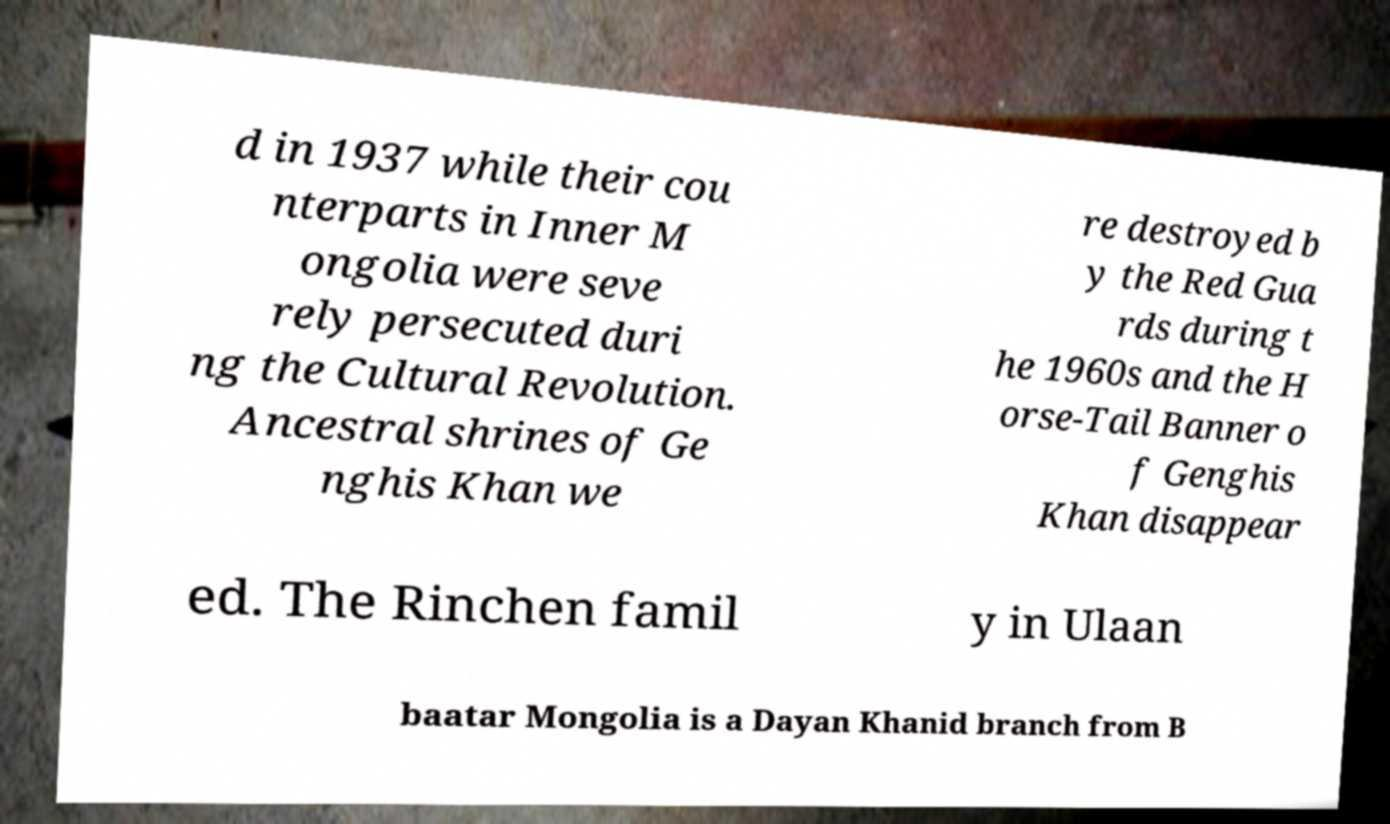Can you read and provide the text displayed in the image?This photo seems to have some interesting text. Can you extract and type it out for me? d in 1937 while their cou nterparts in Inner M ongolia were seve rely persecuted duri ng the Cultural Revolution. Ancestral shrines of Ge nghis Khan we re destroyed b y the Red Gua rds during t he 1960s and the H orse-Tail Banner o f Genghis Khan disappear ed. The Rinchen famil y in Ulaan baatar Mongolia is a Dayan Khanid branch from B 